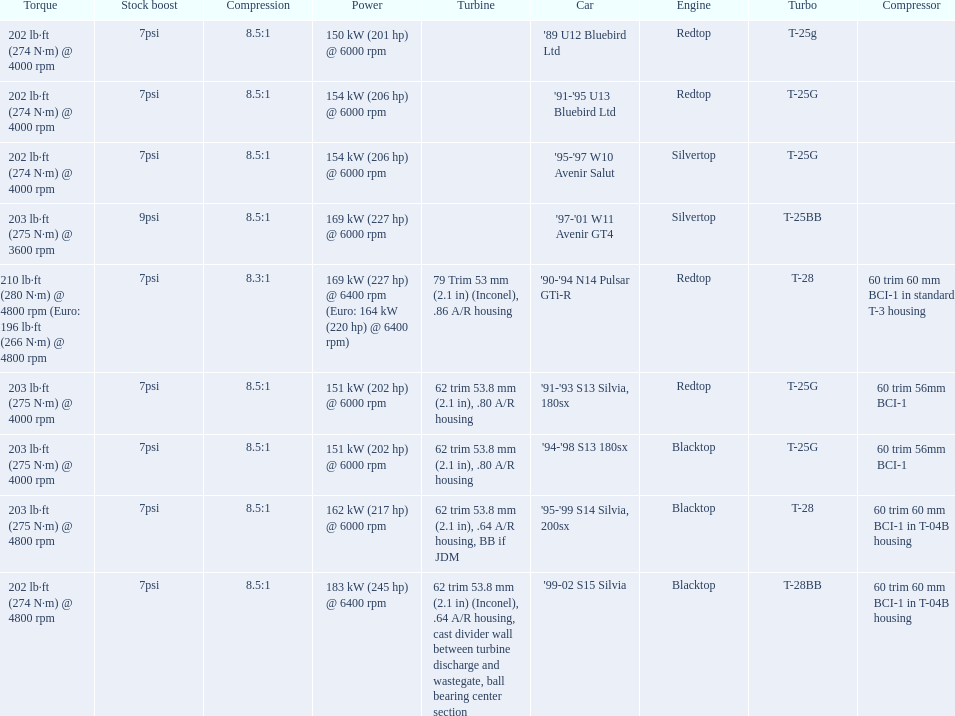Which cars list turbine details? '90-'94 N14 Pulsar GTi-R, '91-'93 S13 Silvia, 180sx, '94-'98 S13 180sx, '95-'99 S14 Silvia, 200sx, '99-02 S15 Silvia. Which of these hit their peak hp at the highest rpm? '90-'94 N14 Pulsar GTi-R, '99-02 S15 Silvia. Of those what is the compression of the only engine that isn't blacktop?? 8.3:1. 